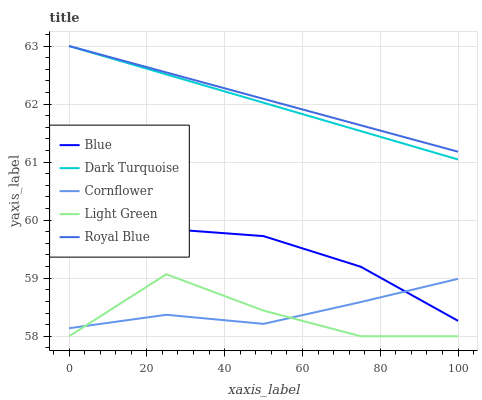Does Light Green have the minimum area under the curve?
Answer yes or no. Yes. Does Royal Blue have the maximum area under the curve?
Answer yes or no. Yes. Does Dark Turquoise have the minimum area under the curve?
Answer yes or no. No. Does Dark Turquoise have the maximum area under the curve?
Answer yes or no. No. Is Dark Turquoise the smoothest?
Answer yes or no. Yes. Is Light Green the roughest?
Answer yes or no. Yes. Is Royal Blue the smoothest?
Answer yes or no. No. Is Royal Blue the roughest?
Answer yes or no. No. Does Light Green have the lowest value?
Answer yes or no. Yes. Does Dark Turquoise have the lowest value?
Answer yes or no. No. Does Royal Blue have the highest value?
Answer yes or no. Yes. Does Light Green have the highest value?
Answer yes or no. No. Is Light Green less than Royal Blue?
Answer yes or no. Yes. Is Royal Blue greater than Cornflower?
Answer yes or no. Yes. Does Royal Blue intersect Dark Turquoise?
Answer yes or no. Yes. Is Royal Blue less than Dark Turquoise?
Answer yes or no. No. Is Royal Blue greater than Dark Turquoise?
Answer yes or no. No. Does Light Green intersect Royal Blue?
Answer yes or no. No. 